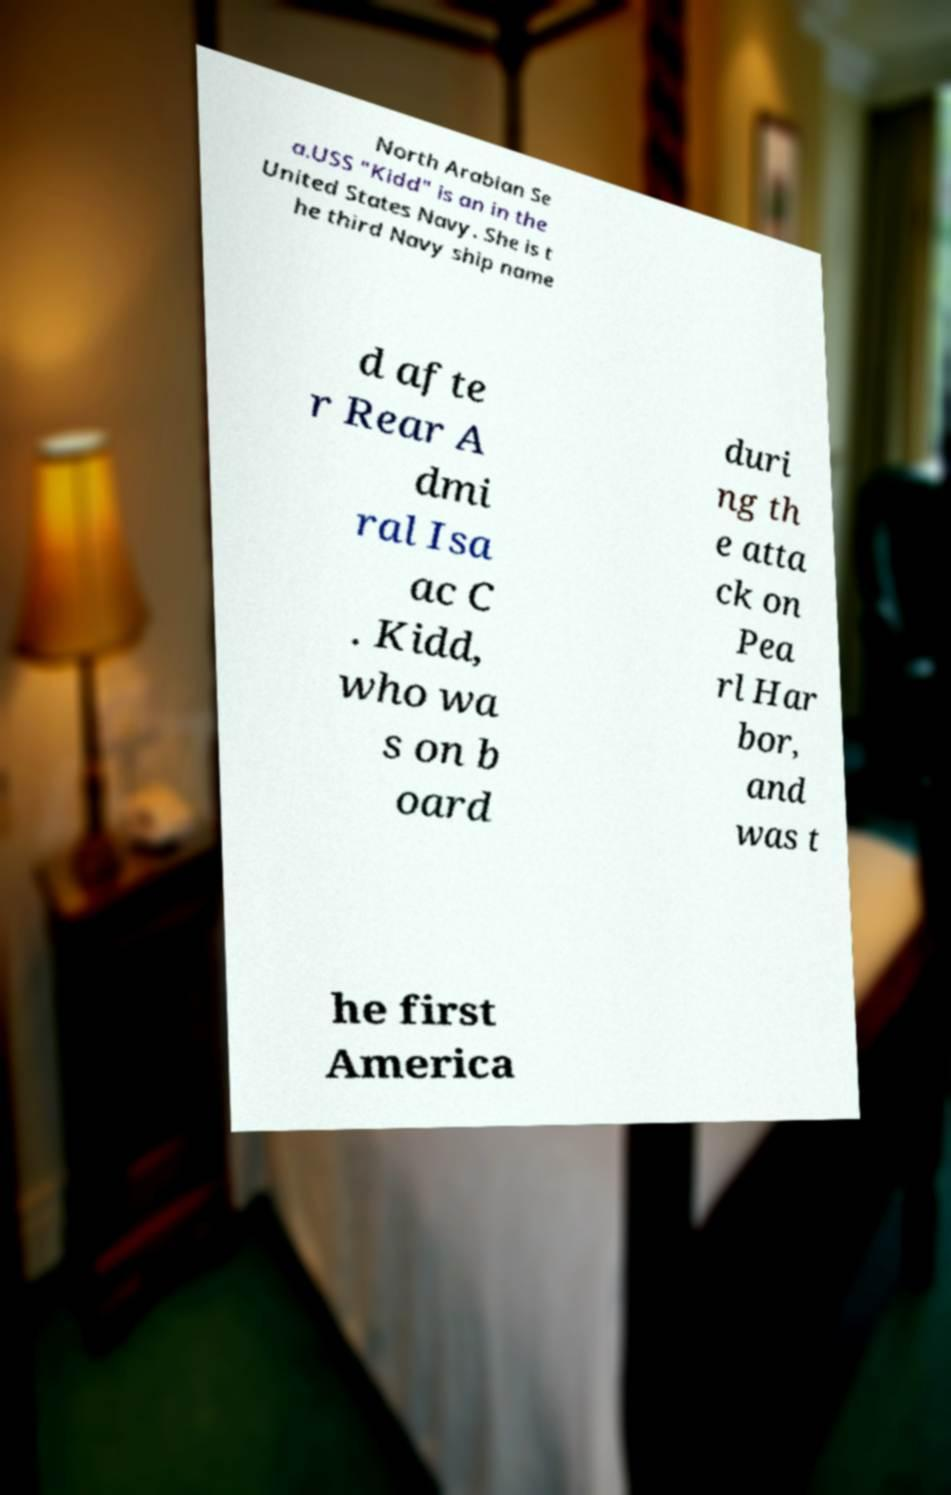There's text embedded in this image that I need extracted. Can you transcribe it verbatim? North Arabian Se a.USS "Kidd" is an in the United States Navy. She is t he third Navy ship name d afte r Rear A dmi ral Isa ac C . Kidd, who wa s on b oard duri ng th e atta ck on Pea rl Har bor, and was t he first America 